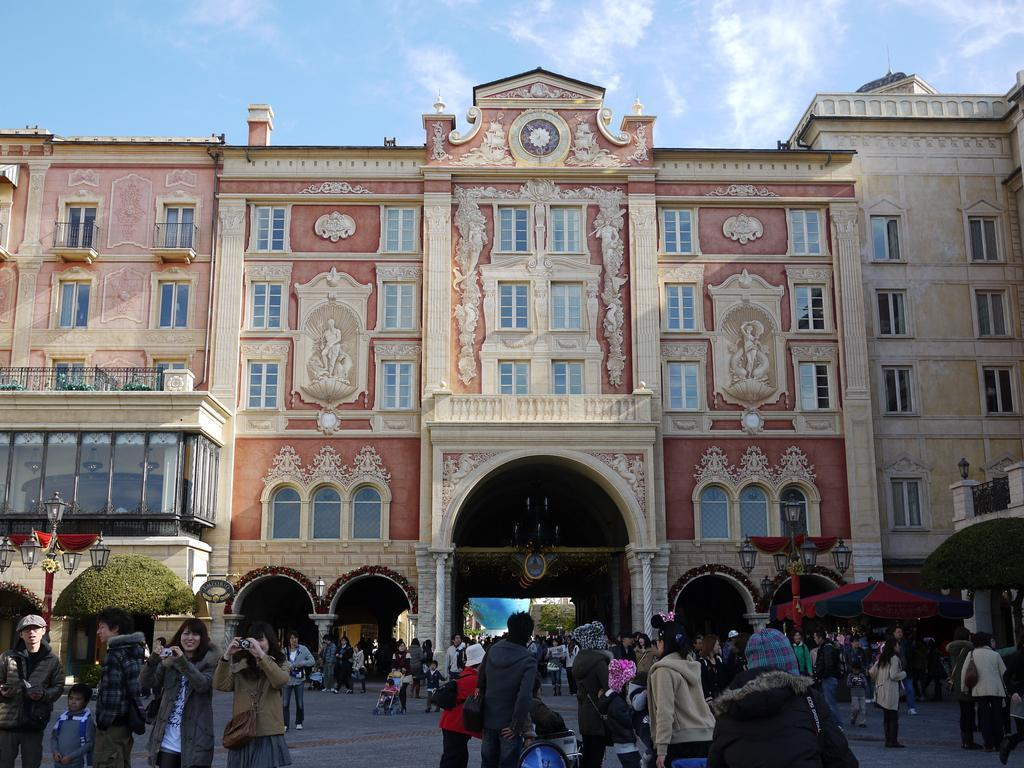What is happening in the foreground of the image? There are people standing and moving on the road in the foreground. What can be seen on either side of the road? There are light poles on either side of the road. What is visible in the background of the image? There is a building in the background, and the sky is visible. What is the condition of the sky in the image? Clouds are present in the sky. How many roses are being carried by the people in the image? There are no roses visible in the image; people are standing and moving on the road. What type of chairs can be seen in the image? There are no chairs present in the image. 